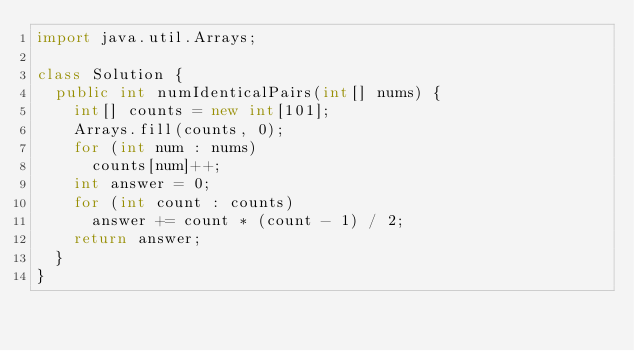<code> <loc_0><loc_0><loc_500><loc_500><_Java_>import java.util.Arrays;

class Solution {
  public int numIdenticalPairs(int[] nums) {
    int[] counts = new int[101];
    Arrays.fill(counts, 0);
    for (int num : nums)
      counts[num]++;
    int answer = 0;
    for (int count : counts)
      answer += count * (count - 1) / 2;
    return answer;
  }
}
</code> 